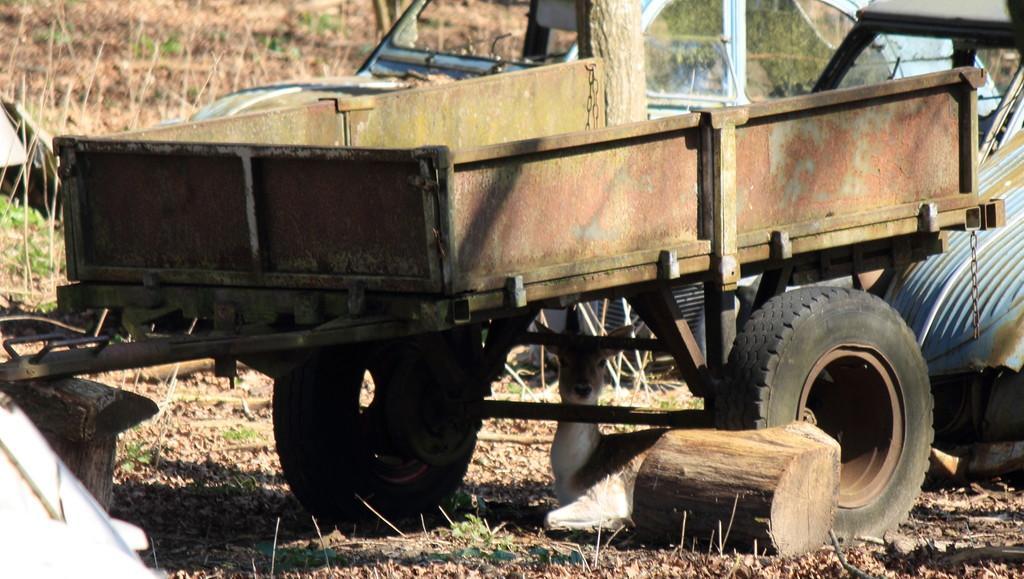Please provide a concise description of this image. In this image I can see vehicles on the ground, wood, animal, grass and plants. This image is taken may be during a day. 